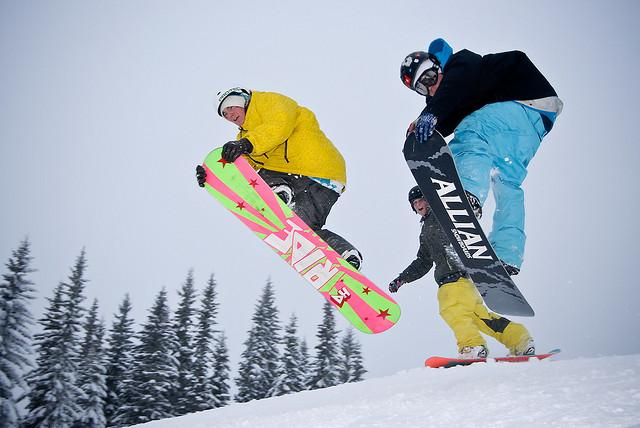What have these children likely practiced? snowboarding 